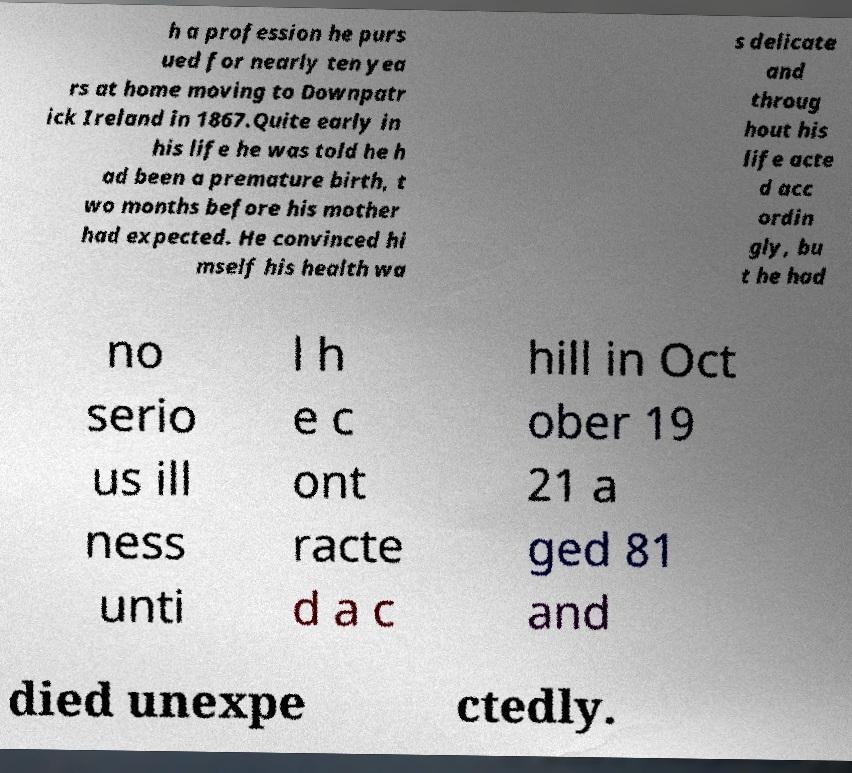Please read and relay the text visible in this image. What does it say? h a profession he purs ued for nearly ten yea rs at home moving to Downpatr ick Ireland in 1867.Quite early in his life he was told he h ad been a premature birth, t wo months before his mother had expected. He convinced hi mself his health wa s delicate and throug hout his life acte d acc ordin gly, bu t he had no serio us ill ness unti l h e c ont racte d a c hill in Oct ober 19 21 a ged 81 and died unexpe ctedly. 